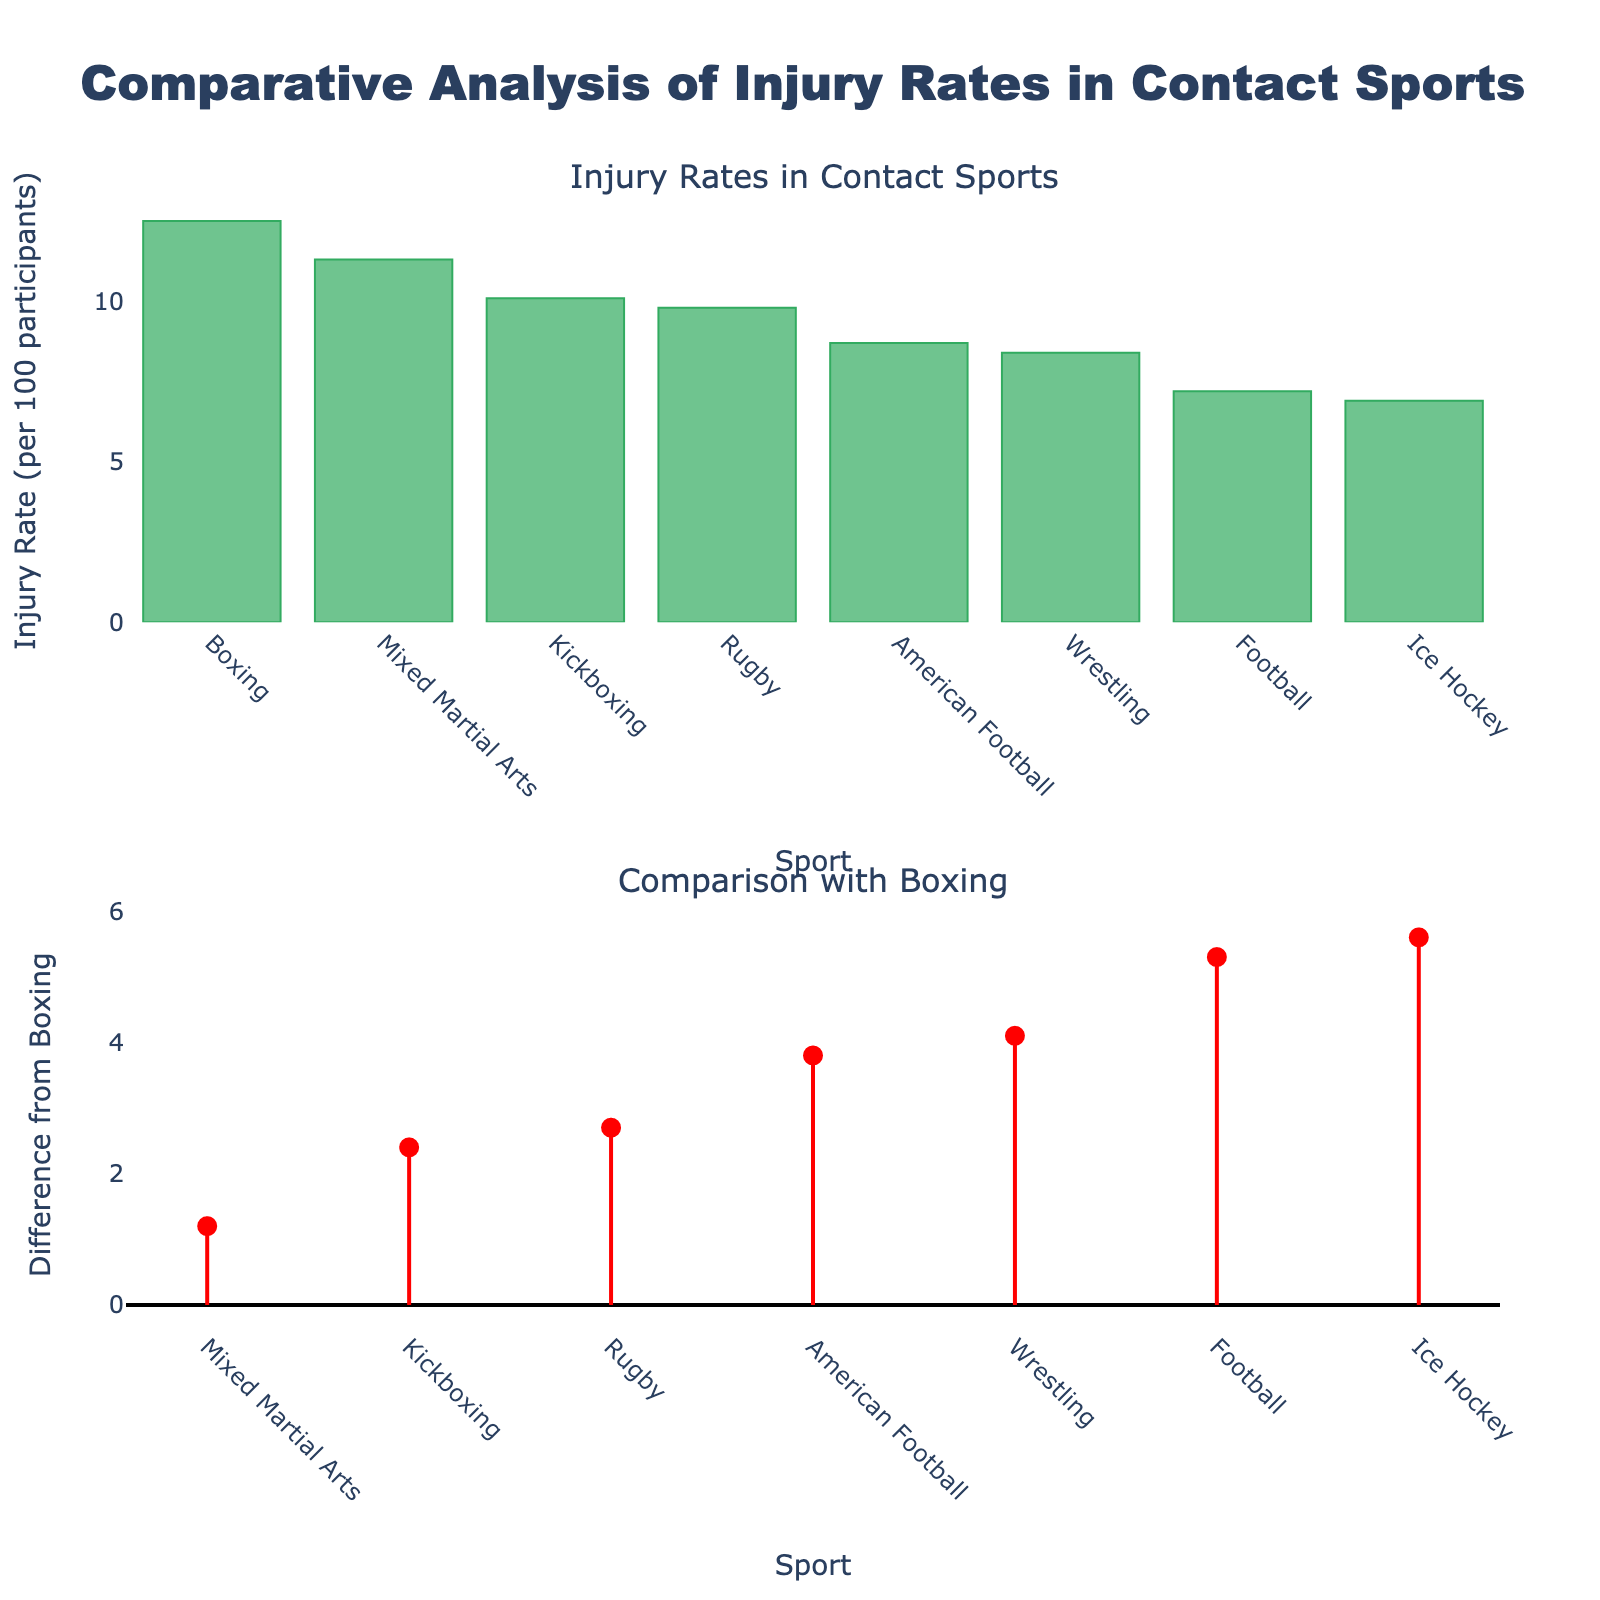What is the title of the figure? The title of the entire figure is shown at the top of the plot.
Answer: Comparative Analysis of Injury Rates in Contact Sports Which sport has the highest injury rate? Look at the highest bar in the bar chart on the top subplot.
Answer: Boxing What is the injury rate for Rugby? Identify the height of the bar labeled "Rugby" in the top subplot.
Answer: 9.8 per 100 participants How does the injury rate of Mixed Martial Arts compare to that of Boxing? Check the length of the line from the x-axis to the marker in the second subplot corresponding to 'Mixed Martial Arts' to see if it's above or below zero.
Answer: Lower than Boxing Which sport shows the largest difference in injury rate compared to Boxing? Look at the second subplot and identify the longest red-colored line.
Answer: Ice Hockey What is the injury rate for Ice Hockey and how does it compare to Boxing? Identify the height of the bar labeled "Ice Hockey" in the top subplot, then compare it to the injury rate of Boxing.
Answer: 6.9 per 100 participants; lower than Boxing What is the injury rate for Kickboxing? Identify the height of the bar labeled "Kickboxing" in the top subplot.
Answer: 10.1 per 100 participants How many sports have an injury rate lower than Boxing? Count the number of bars shorter than the bar for Boxing in the top subplot.
Answer: 7 sports What is the difference in injury rate between Boxing and American Football? Identify the height of the bar for American Football and subtract it from the height of the bar for Boxing.
Answer: 3.8 per 100 participants 